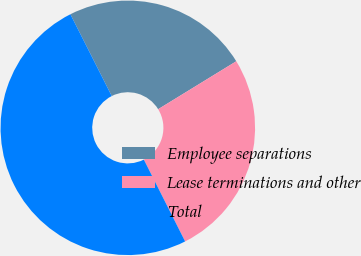Convert chart. <chart><loc_0><loc_0><loc_500><loc_500><pie_chart><fcel>Employee separations<fcel>Lease terminations and other<fcel>Total<nl><fcel>23.69%<fcel>26.32%<fcel>49.98%<nl></chart> 